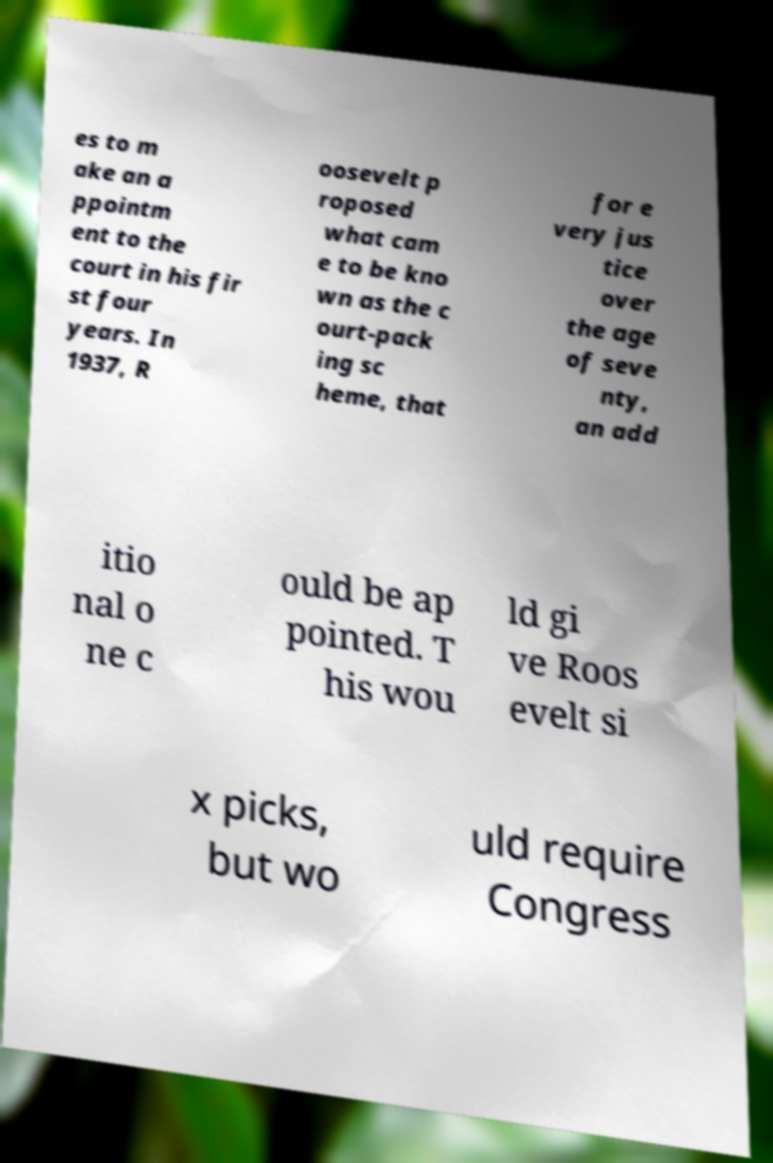There's text embedded in this image that I need extracted. Can you transcribe it verbatim? es to m ake an a ppointm ent to the court in his fir st four years. In 1937, R oosevelt p roposed what cam e to be kno wn as the c ourt-pack ing sc heme, that for e very jus tice over the age of seve nty, an add itio nal o ne c ould be ap pointed. T his wou ld gi ve Roos evelt si x picks, but wo uld require Congress 